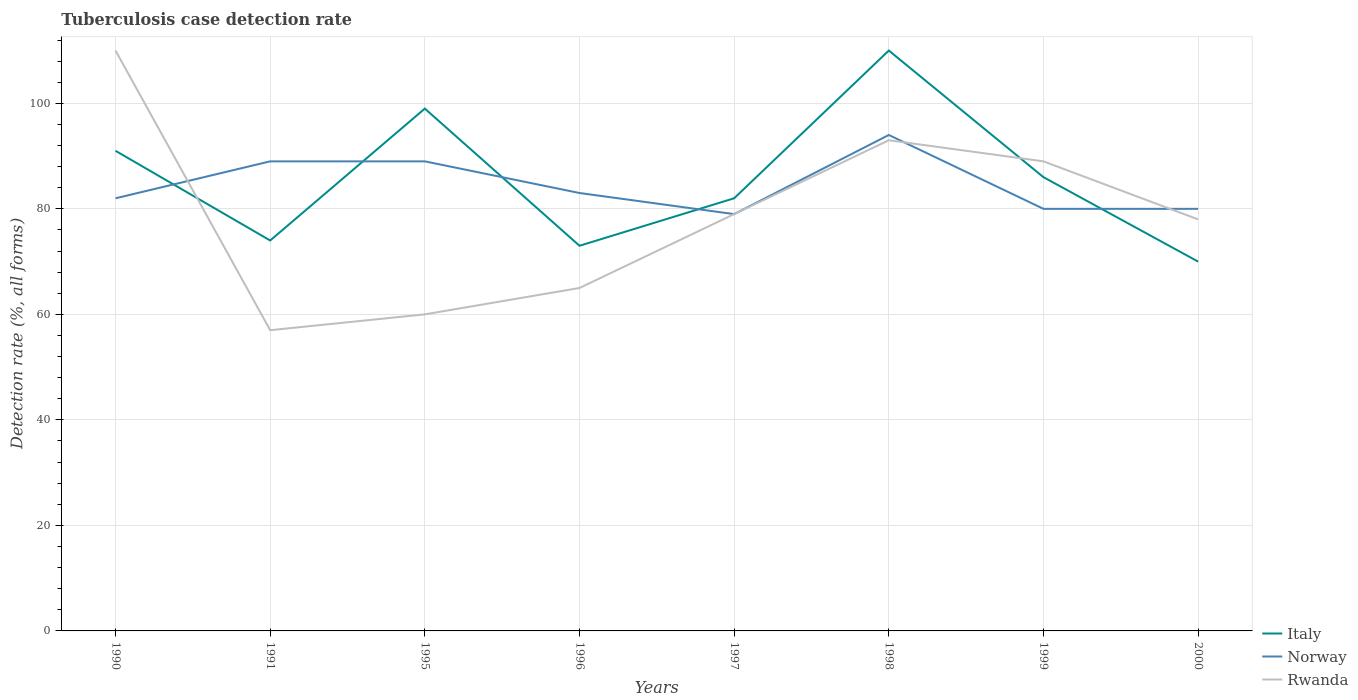Does the line corresponding to Rwanda intersect with the line corresponding to Italy?
Give a very brief answer. Yes. Across all years, what is the maximum tuberculosis case detection rate in in Norway?
Provide a succinct answer. 79. In which year was the tuberculosis case detection rate in in Norway maximum?
Your response must be concise. 1997. What is the total tuberculosis case detection rate in in Norway in the graph?
Keep it short and to the point. -5. What is the difference between the highest and the second highest tuberculosis case detection rate in in Norway?
Provide a short and direct response. 15. What is the difference between the highest and the lowest tuberculosis case detection rate in in Rwanda?
Keep it short and to the point. 4. How many years are there in the graph?
Your answer should be compact. 8. What is the title of the graph?
Offer a terse response. Tuberculosis case detection rate. Does "Singapore" appear as one of the legend labels in the graph?
Offer a very short reply. No. What is the label or title of the X-axis?
Keep it short and to the point. Years. What is the label or title of the Y-axis?
Your answer should be very brief. Detection rate (%, all forms). What is the Detection rate (%, all forms) in Italy in 1990?
Your answer should be compact. 91. What is the Detection rate (%, all forms) of Rwanda in 1990?
Your answer should be compact. 110. What is the Detection rate (%, all forms) of Italy in 1991?
Make the answer very short. 74. What is the Detection rate (%, all forms) in Norway in 1991?
Ensure brevity in your answer.  89. What is the Detection rate (%, all forms) in Italy in 1995?
Offer a terse response. 99. What is the Detection rate (%, all forms) of Norway in 1995?
Offer a terse response. 89. What is the Detection rate (%, all forms) of Italy in 1996?
Your response must be concise. 73. What is the Detection rate (%, all forms) of Rwanda in 1996?
Ensure brevity in your answer.  65. What is the Detection rate (%, all forms) in Norway in 1997?
Make the answer very short. 79. What is the Detection rate (%, all forms) in Rwanda in 1997?
Your answer should be very brief. 79. What is the Detection rate (%, all forms) in Italy in 1998?
Give a very brief answer. 110. What is the Detection rate (%, all forms) of Norway in 1998?
Provide a short and direct response. 94. What is the Detection rate (%, all forms) of Rwanda in 1998?
Ensure brevity in your answer.  93. What is the Detection rate (%, all forms) in Norway in 1999?
Keep it short and to the point. 80. What is the Detection rate (%, all forms) of Rwanda in 1999?
Provide a succinct answer. 89. What is the Detection rate (%, all forms) of Italy in 2000?
Your answer should be very brief. 70. Across all years, what is the maximum Detection rate (%, all forms) of Italy?
Your response must be concise. 110. Across all years, what is the maximum Detection rate (%, all forms) of Norway?
Provide a succinct answer. 94. Across all years, what is the maximum Detection rate (%, all forms) of Rwanda?
Offer a very short reply. 110. Across all years, what is the minimum Detection rate (%, all forms) in Italy?
Your response must be concise. 70. Across all years, what is the minimum Detection rate (%, all forms) of Norway?
Keep it short and to the point. 79. Across all years, what is the minimum Detection rate (%, all forms) in Rwanda?
Offer a terse response. 57. What is the total Detection rate (%, all forms) in Italy in the graph?
Your answer should be compact. 685. What is the total Detection rate (%, all forms) of Norway in the graph?
Make the answer very short. 676. What is the total Detection rate (%, all forms) of Rwanda in the graph?
Offer a terse response. 631. What is the difference between the Detection rate (%, all forms) of Italy in 1990 and that in 1991?
Keep it short and to the point. 17. What is the difference between the Detection rate (%, all forms) of Norway in 1990 and that in 1995?
Keep it short and to the point. -7. What is the difference between the Detection rate (%, all forms) of Rwanda in 1990 and that in 1995?
Offer a terse response. 50. What is the difference between the Detection rate (%, all forms) of Italy in 1990 and that in 1996?
Ensure brevity in your answer.  18. What is the difference between the Detection rate (%, all forms) of Norway in 1990 and that in 1997?
Make the answer very short. 3. What is the difference between the Detection rate (%, all forms) in Rwanda in 1990 and that in 1997?
Provide a short and direct response. 31. What is the difference between the Detection rate (%, all forms) in Norway in 1990 and that in 1998?
Make the answer very short. -12. What is the difference between the Detection rate (%, all forms) of Italy in 1990 and that in 1999?
Your answer should be very brief. 5. What is the difference between the Detection rate (%, all forms) in Italy in 1990 and that in 2000?
Your answer should be compact. 21. What is the difference between the Detection rate (%, all forms) in Norway in 1990 and that in 2000?
Offer a terse response. 2. What is the difference between the Detection rate (%, all forms) in Rwanda in 1990 and that in 2000?
Your response must be concise. 32. What is the difference between the Detection rate (%, all forms) in Rwanda in 1991 and that in 1995?
Provide a short and direct response. -3. What is the difference between the Detection rate (%, all forms) of Norway in 1991 and that in 1997?
Provide a succinct answer. 10. What is the difference between the Detection rate (%, all forms) in Rwanda in 1991 and that in 1997?
Provide a succinct answer. -22. What is the difference between the Detection rate (%, all forms) of Italy in 1991 and that in 1998?
Provide a succinct answer. -36. What is the difference between the Detection rate (%, all forms) of Norway in 1991 and that in 1998?
Offer a terse response. -5. What is the difference between the Detection rate (%, all forms) in Rwanda in 1991 and that in 1998?
Give a very brief answer. -36. What is the difference between the Detection rate (%, all forms) in Rwanda in 1991 and that in 1999?
Your answer should be very brief. -32. What is the difference between the Detection rate (%, all forms) in Norway in 1991 and that in 2000?
Keep it short and to the point. 9. What is the difference between the Detection rate (%, all forms) in Italy in 1995 and that in 1996?
Your answer should be very brief. 26. What is the difference between the Detection rate (%, all forms) in Norway in 1995 and that in 1996?
Your response must be concise. 6. What is the difference between the Detection rate (%, all forms) of Norway in 1995 and that in 1997?
Make the answer very short. 10. What is the difference between the Detection rate (%, all forms) of Italy in 1995 and that in 1998?
Make the answer very short. -11. What is the difference between the Detection rate (%, all forms) in Rwanda in 1995 and that in 1998?
Make the answer very short. -33. What is the difference between the Detection rate (%, all forms) of Norway in 1995 and that in 1999?
Ensure brevity in your answer.  9. What is the difference between the Detection rate (%, all forms) in Rwanda in 1995 and that in 1999?
Your response must be concise. -29. What is the difference between the Detection rate (%, all forms) in Italy in 1995 and that in 2000?
Offer a terse response. 29. What is the difference between the Detection rate (%, all forms) in Norway in 1995 and that in 2000?
Provide a succinct answer. 9. What is the difference between the Detection rate (%, all forms) of Norway in 1996 and that in 1997?
Offer a terse response. 4. What is the difference between the Detection rate (%, all forms) of Rwanda in 1996 and that in 1997?
Your answer should be very brief. -14. What is the difference between the Detection rate (%, all forms) of Italy in 1996 and that in 1998?
Keep it short and to the point. -37. What is the difference between the Detection rate (%, all forms) in Rwanda in 1996 and that in 1998?
Offer a very short reply. -28. What is the difference between the Detection rate (%, all forms) of Rwanda in 1996 and that in 1999?
Give a very brief answer. -24. What is the difference between the Detection rate (%, all forms) of Italy in 1996 and that in 2000?
Your answer should be compact. 3. What is the difference between the Detection rate (%, all forms) in Norway in 1996 and that in 2000?
Your answer should be compact. 3. What is the difference between the Detection rate (%, all forms) of Italy in 1997 and that in 1998?
Your answer should be compact. -28. What is the difference between the Detection rate (%, all forms) of Rwanda in 1997 and that in 1998?
Your answer should be compact. -14. What is the difference between the Detection rate (%, all forms) in Italy in 1997 and that in 1999?
Offer a very short reply. -4. What is the difference between the Detection rate (%, all forms) in Norway in 1997 and that in 1999?
Provide a succinct answer. -1. What is the difference between the Detection rate (%, all forms) of Rwanda in 1997 and that in 2000?
Give a very brief answer. 1. What is the difference between the Detection rate (%, all forms) of Norway in 1998 and that in 1999?
Offer a very short reply. 14. What is the difference between the Detection rate (%, all forms) in Rwanda in 1998 and that in 1999?
Offer a terse response. 4. What is the difference between the Detection rate (%, all forms) of Italy in 1999 and that in 2000?
Offer a terse response. 16. What is the difference between the Detection rate (%, all forms) in Norway in 1999 and that in 2000?
Your answer should be compact. 0. What is the difference between the Detection rate (%, all forms) of Rwanda in 1999 and that in 2000?
Keep it short and to the point. 11. What is the difference between the Detection rate (%, all forms) in Italy in 1990 and the Detection rate (%, all forms) in Rwanda in 1991?
Your answer should be compact. 34. What is the difference between the Detection rate (%, all forms) in Norway in 1990 and the Detection rate (%, all forms) in Rwanda in 1991?
Your answer should be compact. 25. What is the difference between the Detection rate (%, all forms) of Italy in 1990 and the Detection rate (%, all forms) of Norway in 1995?
Offer a terse response. 2. What is the difference between the Detection rate (%, all forms) in Italy in 1990 and the Detection rate (%, all forms) in Rwanda in 1995?
Your answer should be compact. 31. What is the difference between the Detection rate (%, all forms) in Norway in 1990 and the Detection rate (%, all forms) in Rwanda in 1995?
Your response must be concise. 22. What is the difference between the Detection rate (%, all forms) of Italy in 1990 and the Detection rate (%, all forms) of Norway in 1996?
Your answer should be compact. 8. What is the difference between the Detection rate (%, all forms) of Italy in 1990 and the Detection rate (%, all forms) of Rwanda in 1997?
Provide a short and direct response. 12. What is the difference between the Detection rate (%, all forms) in Norway in 1990 and the Detection rate (%, all forms) in Rwanda in 1997?
Offer a very short reply. 3. What is the difference between the Detection rate (%, all forms) of Italy in 1990 and the Detection rate (%, all forms) of Norway in 1998?
Make the answer very short. -3. What is the difference between the Detection rate (%, all forms) in Italy in 1990 and the Detection rate (%, all forms) in Rwanda in 1998?
Provide a succinct answer. -2. What is the difference between the Detection rate (%, all forms) in Norway in 1990 and the Detection rate (%, all forms) in Rwanda in 1998?
Offer a terse response. -11. What is the difference between the Detection rate (%, all forms) of Italy in 1990 and the Detection rate (%, all forms) of Norway in 1999?
Make the answer very short. 11. What is the difference between the Detection rate (%, all forms) in Norway in 1990 and the Detection rate (%, all forms) in Rwanda in 1999?
Provide a short and direct response. -7. What is the difference between the Detection rate (%, all forms) of Italy in 1990 and the Detection rate (%, all forms) of Rwanda in 2000?
Your answer should be compact. 13. What is the difference between the Detection rate (%, all forms) in Norway in 1990 and the Detection rate (%, all forms) in Rwanda in 2000?
Keep it short and to the point. 4. What is the difference between the Detection rate (%, all forms) of Italy in 1991 and the Detection rate (%, all forms) of Norway in 1995?
Your answer should be very brief. -15. What is the difference between the Detection rate (%, all forms) in Norway in 1991 and the Detection rate (%, all forms) in Rwanda in 1995?
Offer a terse response. 29. What is the difference between the Detection rate (%, all forms) of Italy in 1991 and the Detection rate (%, all forms) of Norway in 1996?
Offer a very short reply. -9. What is the difference between the Detection rate (%, all forms) of Norway in 1991 and the Detection rate (%, all forms) of Rwanda in 1996?
Keep it short and to the point. 24. What is the difference between the Detection rate (%, all forms) in Italy in 1991 and the Detection rate (%, all forms) in Norway in 1997?
Give a very brief answer. -5. What is the difference between the Detection rate (%, all forms) of Norway in 1991 and the Detection rate (%, all forms) of Rwanda in 1997?
Offer a terse response. 10. What is the difference between the Detection rate (%, all forms) of Italy in 1991 and the Detection rate (%, all forms) of Rwanda in 1998?
Your answer should be compact. -19. What is the difference between the Detection rate (%, all forms) of Italy in 1991 and the Detection rate (%, all forms) of Norway in 2000?
Provide a succinct answer. -6. What is the difference between the Detection rate (%, all forms) of Norway in 1991 and the Detection rate (%, all forms) of Rwanda in 2000?
Ensure brevity in your answer.  11. What is the difference between the Detection rate (%, all forms) in Italy in 1995 and the Detection rate (%, all forms) in Rwanda in 1996?
Provide a succinct answer. 34. What is the difference between the Detection rate (%, all forms) in Norway in 1995 and the Detection rate (%, all forms) in Rwanda in 1996?
Offer a very short reply. 24. What is the difference between the Detection rate (%, all forms) in Italy in 1995 and the Detection rate (%, all forms) in Norway in 1997?
Offer a very short reply. 20. What is the difference between the Detection rate (%, all forms) of Norway in 1995 and the Detection rate (%, all forms) of Rwanda in 1997?
Your response must be concise. 10. What is the difference between the Detection rate (%, all forms) of Italy in 1995 and the Detection rate (%, all forms) of Rwanda in 1998?
Give a very brief answer. 6. What is the difference between the Detection rate (%, all forms) in Norway in 1995 and the Detection rate (%, all forms) in Rwanda in 1998?
Provide a short and direct response. -4. What is the difference between the Detection rate (%, all forms) in Italy in 1995 and the Detection rate (%, all forms) in Norway in 1999?
Make the answer very short. 19. What is the difference between the Detection rate (%, all forms) of Italy in 1995 and the Detection rate (%, all forms) of Rwanda in 1999?
Offer a very short reply. 10. What is the difference between the Detection rate (%, all forms) in Norway in 1995 and the Detection rate (%, all forms) in Rwanda in 1999?
Ensure brevity in your answer.  0. What is the difference between the Detection rate (%, all forms) of Italy in 1995 and the Detection rate (%, all forms) of Norway in 2000?
Your answer should be compact. 19. What is the difference between the Detection rate (%, all forms) in Italy in 1995 and the Detection rate (%, all forms) in Rwanda in 2000?
Provide a short and direct response. 21. What is the difference between the Detection rate (%, all forms) of Norway in 1995 and the Detection rate (%, all forms) of Rwanda in 2000?
Provide a succinct answer. 11. What is the difference between the Detection rate (%, all forms) in Italy in 1996 and the Detection rate (%, all forms) in Rwanda in 1997?
Offer a very short reply. -6. What is the difference between the Detection rate (%, all forms) of Italy in 1996 and the Detection rate (%, all forms) of Norway in 1998?
Your answer should be very brief. -21. What is the difference between the Detection rate (%, all forms) in Norway in 1996 and the Detection rate (%, all forms) in Rwanda in 1998?
Your response must be concise. -10. What is the difference between the Detection rate (%, all forms) of Italy in 1996 and the Detection rate (%, all forms) of Rwanda in 1999?
Keep it short and to the point. -16. What is the difference between the Detection rate (%, all forms) of Norway in 1996 and the Detection rate (%, all forms) of Rwanda in 1999?
Give a very brief answer. -6. What is the difference between the Detection rate (%, all forms) in Norway in 1996 and the Detection rate (%, all forms) in Rwanda in 2000?
Provide a succinct answer. 5. What is the difference between the Detection rate (%, all forms) of Norway in 1997 and the Detection rate (%, all forms) of Rwanda in 1998?
Offer a very short reply. -14. What is the difference between the Detection rate (%, all forms) in Norway in 1997 and the Detection rate (%, all forms) in Rwanda in 2000?
Provide a short and direct response. 1. What is the difference between the Detection rate (%, all forms) of Italy in 1998 and the Detection rate (%, all forms) of Norway in 2000?
Offer a terse response. 30. What is the difference between the Detection rate (%, all forms) of Norway in 1998 and the Detection rate (%, all forms) of Rwanda in 2000?
Your response must be concise. 16. What is the difference between the Detection rate (%, all forms) in Italy in 1999 and the Detection rate (%, all forms) in Rwanda in 2000?
Make the answer very short. 8. What is the difference between the Detection rate (%, all forms) of Norway in 1999 and the Detection rate (%, all forms) of Rwanda in 2000?
Your response must be concise. 2. What is the average Detection rate (%, all forms) of Italy per year?
Your answer should be very brief. 85.62. What is the average Detection rate (%, all forms) of Norway per year?
Your answer should be compact. 84.5. What is the average Detection rate (%, all forms) of Rwanda per year?
Your answer should be very brief. 78.88. In the year 1990, what is the difference between the Detection rate (%, all forms) in Italy and Detection rate (%, all forms) in Rwanda?
Your answer should be very brief. -19. In the year 1991, what is the difference between the Detection rate (%, all forms) in Italy and Detection rate (%, all forms) in Norway?
Your response must be concise. -15. In the year 1991, what is the difference between the Detection rate (%, all forms) in Italy and Detection rate (%, all forms) in Rwanda?
Provide a short and direct response. 17. In the year 1995, what is the difference between the Detection rate (%, all forms) of Italy and Detection rate (%, all forms) of Norway?
Your answer should be compact. 10. In the year 1995, what is the difference between the Detection rate (%, all forms) of Norway and Detection rate (%, all forms) of Rwanda?
Provide a short and direct response. 29. In the year 1996, what is the difference between the Detection rate (%, all forms) in Italy and Detection rate (%, all forms) in Norway?
Give a very brief answer. -10. In the year 1996, what is the difference between the Detection rate (%, all forms) in Italy and Detection rate (%, all forms) in Rwanda?
Your response must be concise. 8. In the year 1997, what is the difference between the Detection rate (%, all forms) of Italy and Detection rate (%, all forms) of Norway?
Give a very brief answer. 3. In the year 1997, what is the difference between the Detection rate (%, all forms) of Norway and Detection rate (%, all forms) of Rwanda?
Give a very brief answer. 0. In the year 1998, what is the difference between the Detection rate (%, all forms) of Italy and Detection rate (%, all forms) of Norway?
Your response must be concise. 16. In the year 1998, what is the difference between the Detection rate (%, all forms) of Italy and Detection rate (%, all forms) of Rwanda?
Your response must be concise. 17. In the year 1998, what is the difference between the Detection rate (%, all forms) in Norway and Detection rate (%, all forms) in Rwanda?
Offer a terse response. 1. In the year 1999, what is the difference between the Detection rate (%, all forms) of Italy and Detection rate (%, all forms) of Norway?
Ensure brevity in your answer.  6. In the year 1999, what is the difference between the Detection rate (%, all forms) of Norway and Detection rate (%, all forms) of Rwanda?
Your response must be concise. -9. In the year 2000, what is the difference between the Detection rate (%, all forms) in Italy and Detection rate (%, all forms) in Norway?
Give a very brief answer. -10. What is the ratio of the Detection rate (%, all forms) in Italy in 1990 to that in 1991?
Give a very brief answer. 1.23. What is the ratio of the Detection rate (%, all forms) in Norway in 1990 to that in 1991?
Make the answer very short. 0.92. What is the ratio of the Detection rate (%, all forms) in Rwanda in 1990 to that in 1991?
Your answer should be compact. 1.93. What is the ratio of the Detection rate (%, all forms) of Italy in 1990 to that in 1995?
Your answer should be very brief. 0.92. What is the ratio of the Detection rate (%, all forms) in Norway in 1990 to that in 1995?
Ensure brevity in your answer.  0.92. What is the ratio of the Detection rate (%, all forms) of Rwanda in 1990 to that in 1995?
Your answer should be very brief. 1.83. What is the ratio of the Detection rate (%, all forms) of Italy in 1990 to that in 1996?
Provide a short and direct response. 1.25. What is the ratio of the Detection rate (%, all forms) in Norway in 1990 to that in 1996?
Offer a terse response. 0.99. What is the ratio of the Detection rate (%, all forms) of Rwanda in 1990 to that in 1996?
Provide a succinct answer. 1.69. What is the ratio of the Detection rate (%, all forms) of Italy in 1990 to that in 1997?
Provide a short and direct response. 1.11. What is the ratio of the Detection rate (%, all forms) of Norway in 1990 to that in 1997?
Your answer should be very brief. 1.04. What is the ratio of the Detection rate (%, all forms) of Rwanda in 1990 to that in 1997?
Ensure brevity in your answer.  1.39. What is the ratio of the Detection rate (%, all forms) of Italy in 1990 to that in 1998?
Your response must be concise. 0.83. What is the ratio of the Detection rate (%, all forms) in Norway in 1990 to that in 1998?
Your response must be concise. 0.87. What is the ratio of the Detection rate (%, all forms) in Rwanda in 1990 to that in 1998?
Your response must be concise. 1.18. What is the ratio of the Detection rate (%, all forms) in Italy in 1990 to that in 1999?
Keep it short and to the point. 1.06. What is the ratio of the Detection rate (%, all forms) in Norway in 1990 to that in 1999?
Offer a terse response. 1.02. What is the ratio of the Detection rate (%, all forms) in Rwanda in 1990 to that in 1999?
Make the answer very short. 1.24. What is the ratio of the Detection rate (%, all forms) in Norway in 1990 to that in 2000?
Offer a terse response. 1.02. What is the ratio of the Detection rate (%, all forms) in Rwanda in 1990 to that in 2000?
Offer a terse response. 1.41. What is the ratio of the Detection rate (%, all forms) of Italy in 1991 to that in 1995?
Make the answer very short. 0.75. What is the ratio of the Detection rate (%, all forms) of Norway in 1991 to that in 1995?
Keep it short and to the point. 1. What is the ratio of the Detection rate (%, all forms) of Italy in 1991 to that in 1996?
Make the answer very short. 1.01. What is the ratio of the Detection rate (%, all forms) of Norway in 1991 to that in 1996?
Ensure brevity in your answer.  1.07. What is the ratio of the Detection rate (%, all forms) in Rwanda in 1991 to that in 1996?
Offer a very short reply. 0.88. What is the ratio of the Detection rate (%, all forms) in Italy in 1991 to that in 1997?
Ensure brevity in your answer.  0.9. What is the ratio of the Detection rate (%, all forms) of Norway in 1991 to that in 1997?
Provide a short and direct response. 1.13. What is the ratio of the Detection rate (%, all forms) in Rwanda in 1991 to that in 1997?
Keep it short and to the point. 0.72. What is the ratio of the Detection rate (%, all forms) of Italy in 1991 to that in 1998?
Provide a succinct answer. 0.67. What is the ratio of the Detection rate (%, all forms) of Norway in 1991 to that in 1998?
Offer a very short reply. 0.95. What is the ratio of the Detection rate (%, all forms) of Rwanda in 1991 to that in 1998?
Give a very brief answer. 0.61. What is the ratio of the Detection rate (%, all forms) in Italy in 1991 to that in 1999?
Offer a very short reply. 0.86. What is the ratio of the Detection rate (%, all forms) of Norway in 1991 to that in 1999?
Your answer should be very brief. 1.11. What is the ratio of the Detection rate (%, all forms) of Rwanda in 1991 to that in 1999?
Your answer should be compact. 0.64. What is the ratio of the Detection rate (%, all forms) of Italy in 1991 to that in 2000?
Offer a very short reply. 1.06. What is the ratio of the Detection rate (%, all forms) of Norway in 1991 to that in 2000?
Provide a succinct answer. 1.11. What is the ratio of the Detection rate (%, all forms) of Rwanda in 1991 to that in 2000?
Offer a terse response. 0.73. What is the ratio of the Detection rate (%, all forms) in Italy in 1995 to that in 1996?
Your response must be concise. 1.36. What is the ratio of the Detection rate (%, all forms) of Norway in 1995 to that in 1996?
Offer a very short reply. 1.07. What is the ratio of the Detection rate (%, all forms) of Italy in 1995 to that in 1997?
Keep it short and to the point. 1.21. What is the ratio of the Detection rate (%, all forms) of Norway in 1995 to that in 1997?
Provide a short and direct response. 1.13. What is the ratio of the Detection rate (%, all forms) in Rwanda in 1995 to that in 1997?
Give a very brief answer. 0.76. What is the ratio of the Detection rate (%, all forms) in Norway in 1995 to that in 1998?
Your response must be concise. 0.95. What is the ratio of the Detection rate (%, all forms) in Rwanda in 1995 to that in 1998?
Ensure brevity in your answer.  0.65. What is the ratio of the Detection rate (%, all forms) of Italy in 1995 to that in 1999?
Provide a succinct answer. 1.15. What is the ratio of the Detection rate (%, all forms) in Norway in 1995 to that in 1999?
Your answer should be very brief. 1.11. What is the ratio of the Detection rate (%, all forms) in Rwanda in 1995 to that in 1999?
Keep it short and to the point. 0.67. What is the ratio of the Detection rate (%, all forms) of Italy in 1995 to that in 2000?
Keep it short and to the point. 1.41. What is the ratio of the Detection rate (%, all forms) of Norway in 1995 to that in 2000?
Offer a very short reply. 1.11. What is the ratio of the Detection rate (%, all forms) of Rwanda in 1995 to that in 2000?
Make the answer very short. 0.77. What is the ratio of the Detection rate (%, all forms) of Italy in 1996 to that in 1997?
Your response must be concise. 0.89. What is the ratio of the Detection rate (%, all forms) in Norway in 1996 to that in 1997?
Keep it short and to the point. 1.05. What is the ratio of the Detection rate (%, all forms) in Rwanda in 1996 to that in 1997?
Provide a succinct answer. 0.82. What is the ratio of the Detection rate (%, all forms) in Italy in 1996 to that in 1998?
Ensure brevity in your answer.  0.66. What is the ratio of the Detection rate (%, all forms) in Norway in 1996 to that in 1998?
Ensure brevity in your answer.  0.88. What is the ratio of the Detection rate (%, all forms) of Rwanda in 1996 to that in 1998?
Ensure brevity in your answer.  0.7. What is the ratio of the Detection rate (%, all forms) in Italy in 1996 to that in 1999?
Give a very brief answer. 0.85. What is the ratio of the Detection rate (%, all forms) in Norway in 1996 to that in 1999?
Your response must be concise. 1.04. What is the ratio of the Detection rate (%, all forms) of Rwanda in 1996 to that in 1999?
Keep it short and to the point. 0.73. What is the ratio of the Detection rate (%, all forms) of Italy in 1996 to that in 2000?
Offer a very short reply. 1.04. What is the ratio of the Detection rate (%, all forms) in Norway in 1996 to that in 2000?
Your response must be concise. 1.04. What is the ratio of the Detection rate (%, all forms) in Italy in 1997 to that in 1998?
Offer a very short reply. 0.75. What is the ratio of the Detection rate (%, all forms) in Norway in 1997 to that in 1998?
Provide a short and direct response. 0.84. What is the ratio of the Detection rate (%, all forms) of Rwanda in 1997 to that in 1998?
Give a very brief answer. 0.85. What is the ratio of the Detection rate (%, all forms) in Italy in 1997 to that in 1999?
Your response must be concise. 0.95. What is the ratio of the Detection rate (%, all forms) of Norway in 1997 to that in 1999?
Provide a short and direct response. 0.99. What is the ratio of the Detection rate (%, all forms) in Rwanda in 1997 to that in 1999?
Provide a succinct answer. 0.89. What is the ratio of the Detection rate (%, all forms) of Italy in 1997 to that in 2000?
Provide a succinct answer. 1.17. What is the ratio of the Detection rate (%, all forms) in Norway in 1997 to that in 2000?
Keep it short and to the point. 0.99. What is the ratio of the Detection rate (%, all forms) in Rwanda in 1997 to that in 2000?
Give a very brief answer. 1.01. What is the ratio of the Detection rate (%, all forms) in Italy in 1998 to that in 1999?
Give a very brief answer. 1.28. What is the ratio of the Detection rate (%, all forms) in Norway in 1998 to that in 1999?
Offer a very short reply. 1.18. What is the ratio of the Detection rate (%, all forms) in Rwanda in 1998 to that in 1999?
Offer a terse response. 1.04. What is the ratio of the Detection rate (%, all forms) in Italy in 1998 to that in 2000?
Make the answer very short. 1.57. What is the ratio of the Detection rate (%, all forms) of Norway in 1998 to that in 2000?
Keep it short and to the point. 1.18. What is the ratio of the Detection rate (%, all forms) in Rwanda in 1998 to that in 2000?
Your answer should be very brief. 1.19. What is the ratio of the Detection rate (%, all forms) of Italy in 1999 to that in 2000?
Your answer should be very brief. 1.23. What is the ratio of the Detection rate (%, all forms) of Rwanda in 1999 to that in 2000?
Your answer should be very brief. 1.14. What is the difference between the highest and the second highest Detection rate (%, all forms) in Italy?
Provide a short and direct response. 11. What is the difference between the highest and the second highest Detection rate (%, all forms) in Norway?
Keep it short and to the point. 5. What is the difference between the highest and the second highest Detection rate (%, all forms) of Rwanda?
Your response must be concise. 17. What is the difference between the highest and the lowest Detection rate (%, all forms) of Italy?
Provide a succinct answer. 40. What is the difference between the highest and the lowest Detection rate (%, all forms) of Norway?
Offer a very short reply. 15. 